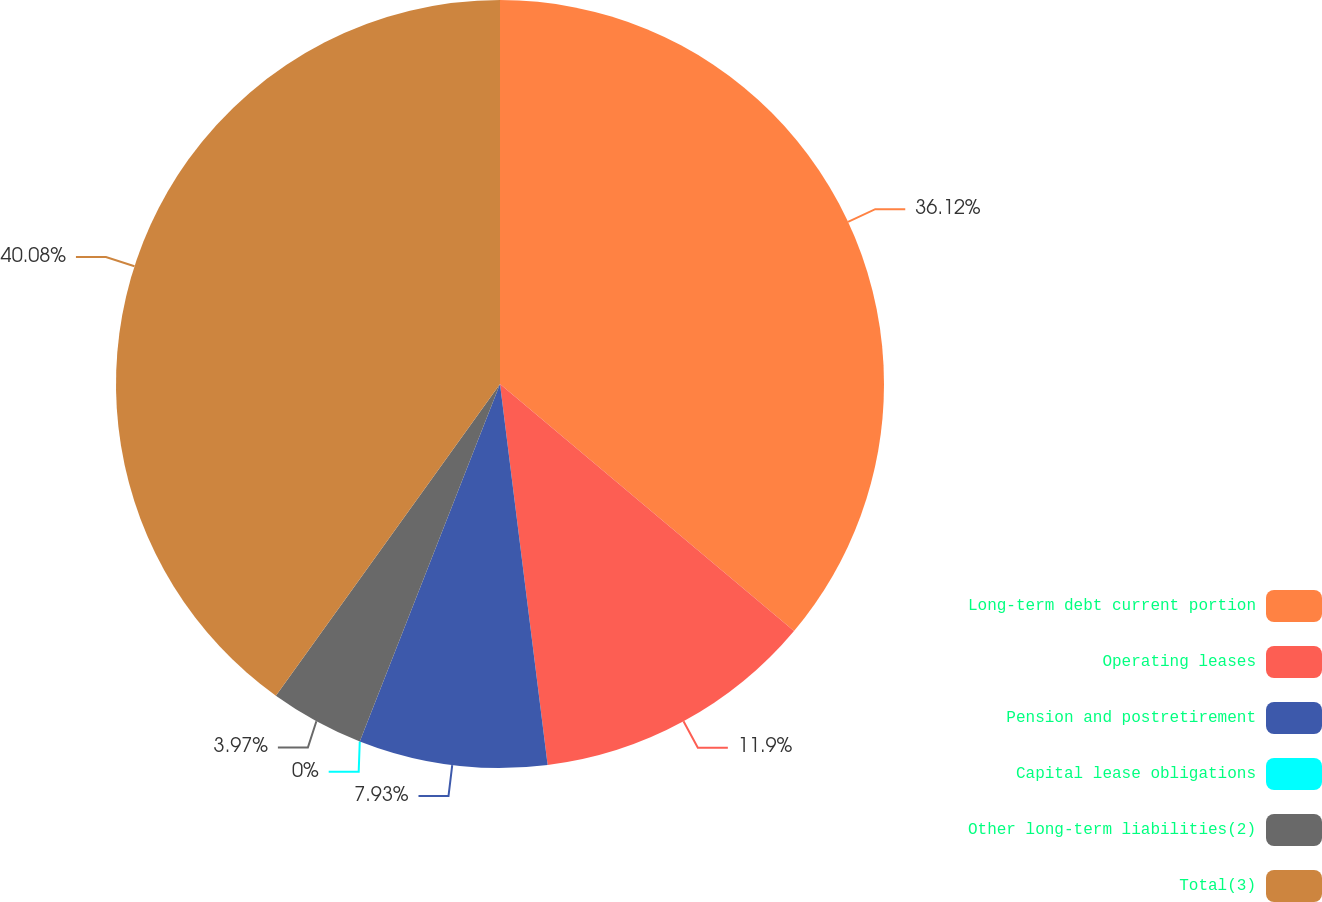<chart> <loc_0><loc_0><loc_500><loc_500><pie_chart><fcel>Long-term debt current portion<fcel>Operating leases<fcel>Pension and postretirement<fcel>Capital lease obligations<fcel>Other long-term liabilities(2)<fcel>Total(3)<nl><fcel>36.12%<fcel>11.9%<fcel>7.93%<fcel>0.0%<fcel>3.97%<fcel>40.08%<nl></chart> 